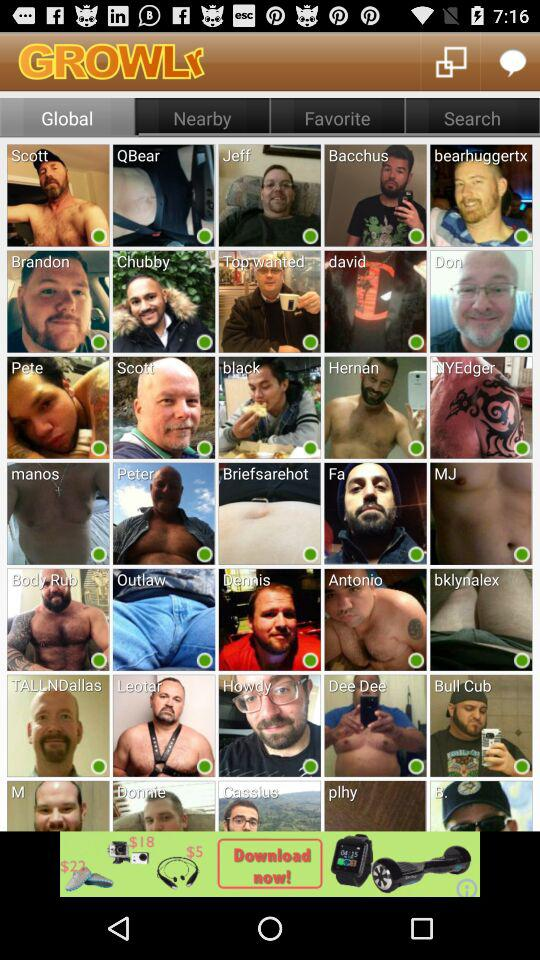Which option has been selected? The option "Global" has been selected. 